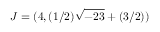Convert formula to latex. <formula><loc_0><loc_0><loc_500><loc_500>J = ( 4 , ( 1 / 2 ) { \sqrt { - 2 3 } } + ( 3 / 2 ) )</formula> 